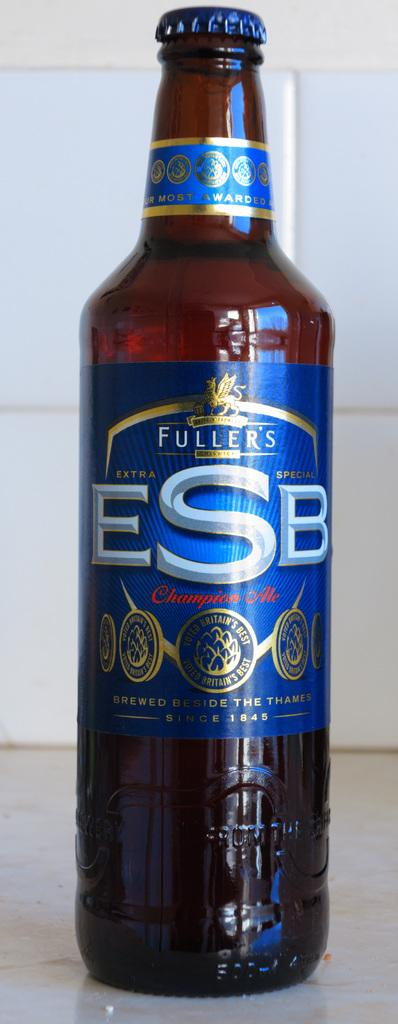<image>
Write a terse but informative summary of the picture. Bottle of Fuller's ESB beer on top of a table. 